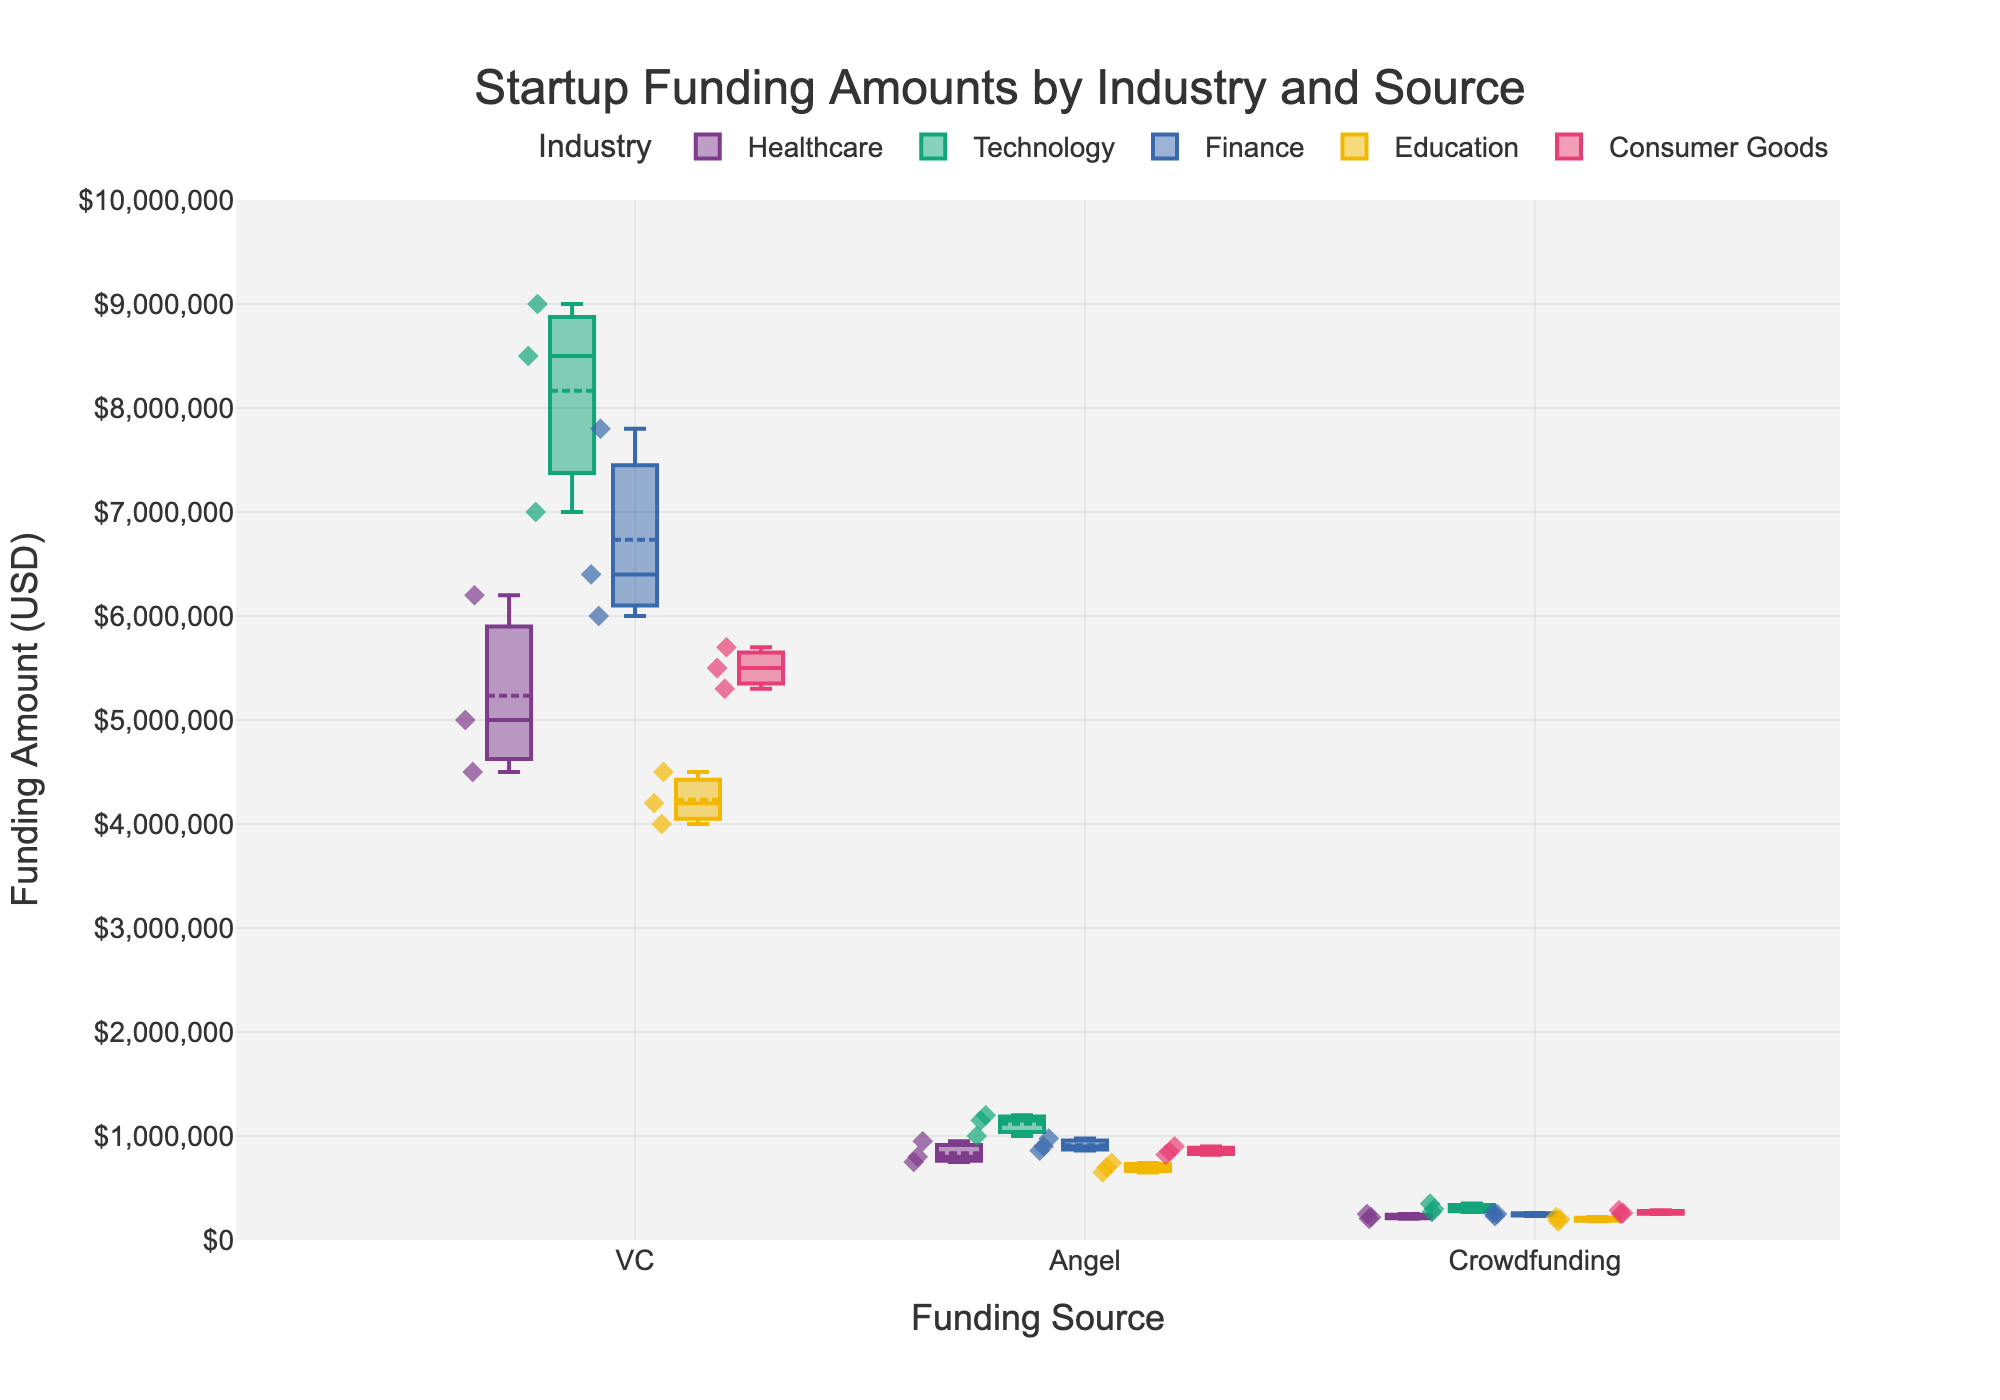What's the title of the figure? The title is typically located at the top of the figure and is meant to provide a brief description of what the figure represents.
Answer: Startup Funding Amounts by Industry and Source What are the three funding sources displayed on the x-axis? The x-axis represents the categories of funding sources. By looking at the labels on the x-axis, we can identify the three funding sources.
Answer: VC, Angel, Crowdfunding Which industry has the highest median funding amount from VC? To determine this, we look for the industry with the highest line in the center of their respective VC box plot.
Answer: Technology What is the range of funding amounts for Healthcare from Crowdfunding? The minimum and maximum points within the vertical extent of the box (including any outliers) for Healthcare funded by Crowdfunding represent the range.
Answer: $205,000 to $250,000 Compare the median funding amounts from Angel investors between Technology and Healthcare. Which is higher? We locate the medians for both industries under the Angel category and compare their positions on the y-axis.
Answer: Technology How many scatter points are plotted for Crowdfunding in the Consumer Goods industry? Count the number of diamond-shaped points located within the Crowdfunding category for Consumer Goods.
Answer: 3 What's the median funding amount for Education from Angel investors? The median is the middle line inside the Angel investor box plot for Education.
Answer: $700,000 In which industry is the variability (range) of VC funding amounts the highest? The variability can be assessed by comparing the lengths of the box plots (including whiskers) for each industry under the VC category. The one with the longest range represents the highest variability.
Answer: Technology What is the overall trend in funding amounts moving from VC to Angel to Crowdfunding across industries? Observing the box plots for each industry category, we see how the median and spread of funding amounts change from one funding source to the next. Generally, this requires noting the shifts and reductions in values.
Answer: Decrease in funding amounts Which funding source generally provides the lowest amounts for Finance? By comparing the median lines and the overall spread within each funding source category for Finance, we see which one consistently shows lower values.
Answer: Crowdfunding 